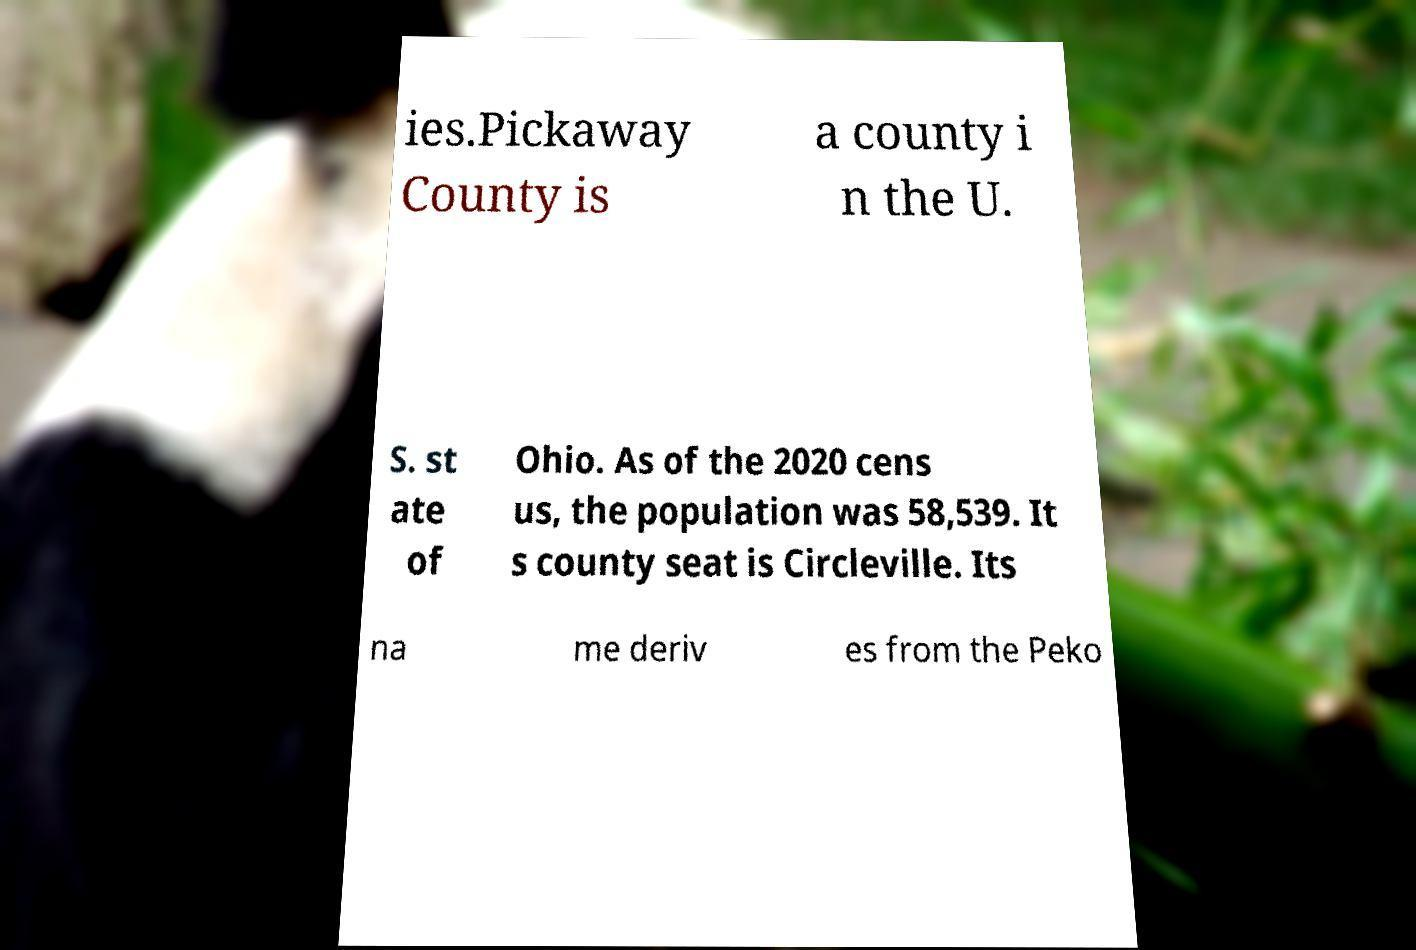Can you read and provide the text displayed in the image?This photo seems to have some interesting text. Can you extract and type it out for me? ies.Pickaway County is a county i n the U. S. st ate of Ohio. As of the 2020 cens us, the population was 58,539. It s county seat is Circleville. Its na me deriv es from the Peko 